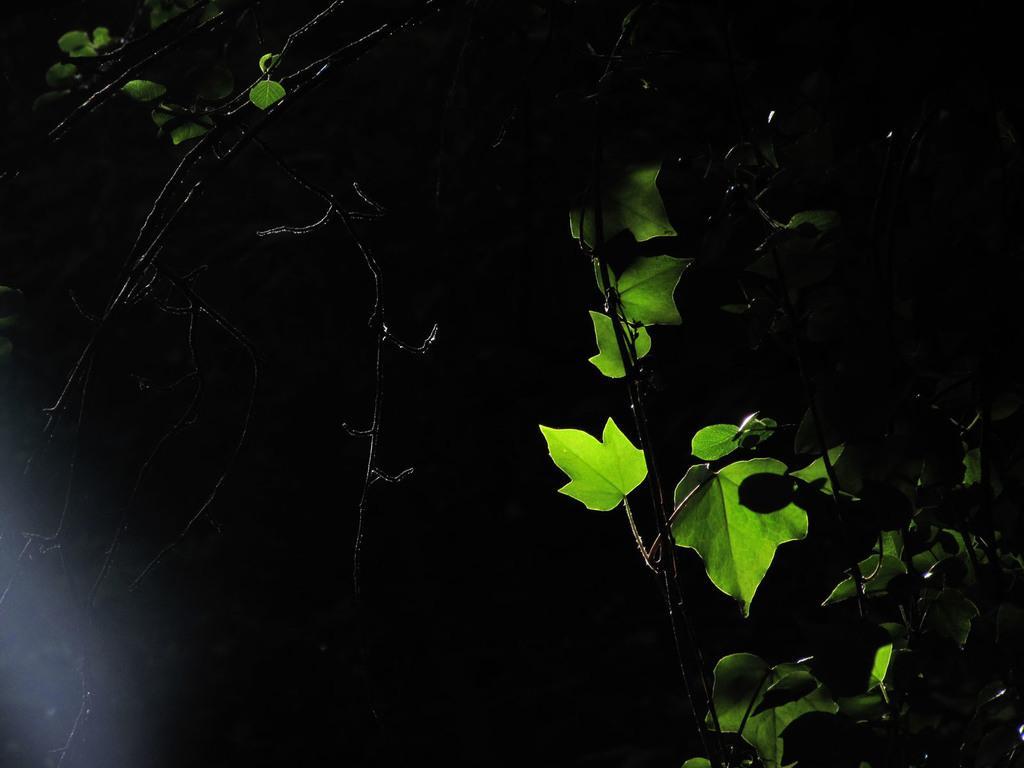Could you give a brief overview of what you see in this image? In this image, we can see plants with leaves and in the background, it is dark. 